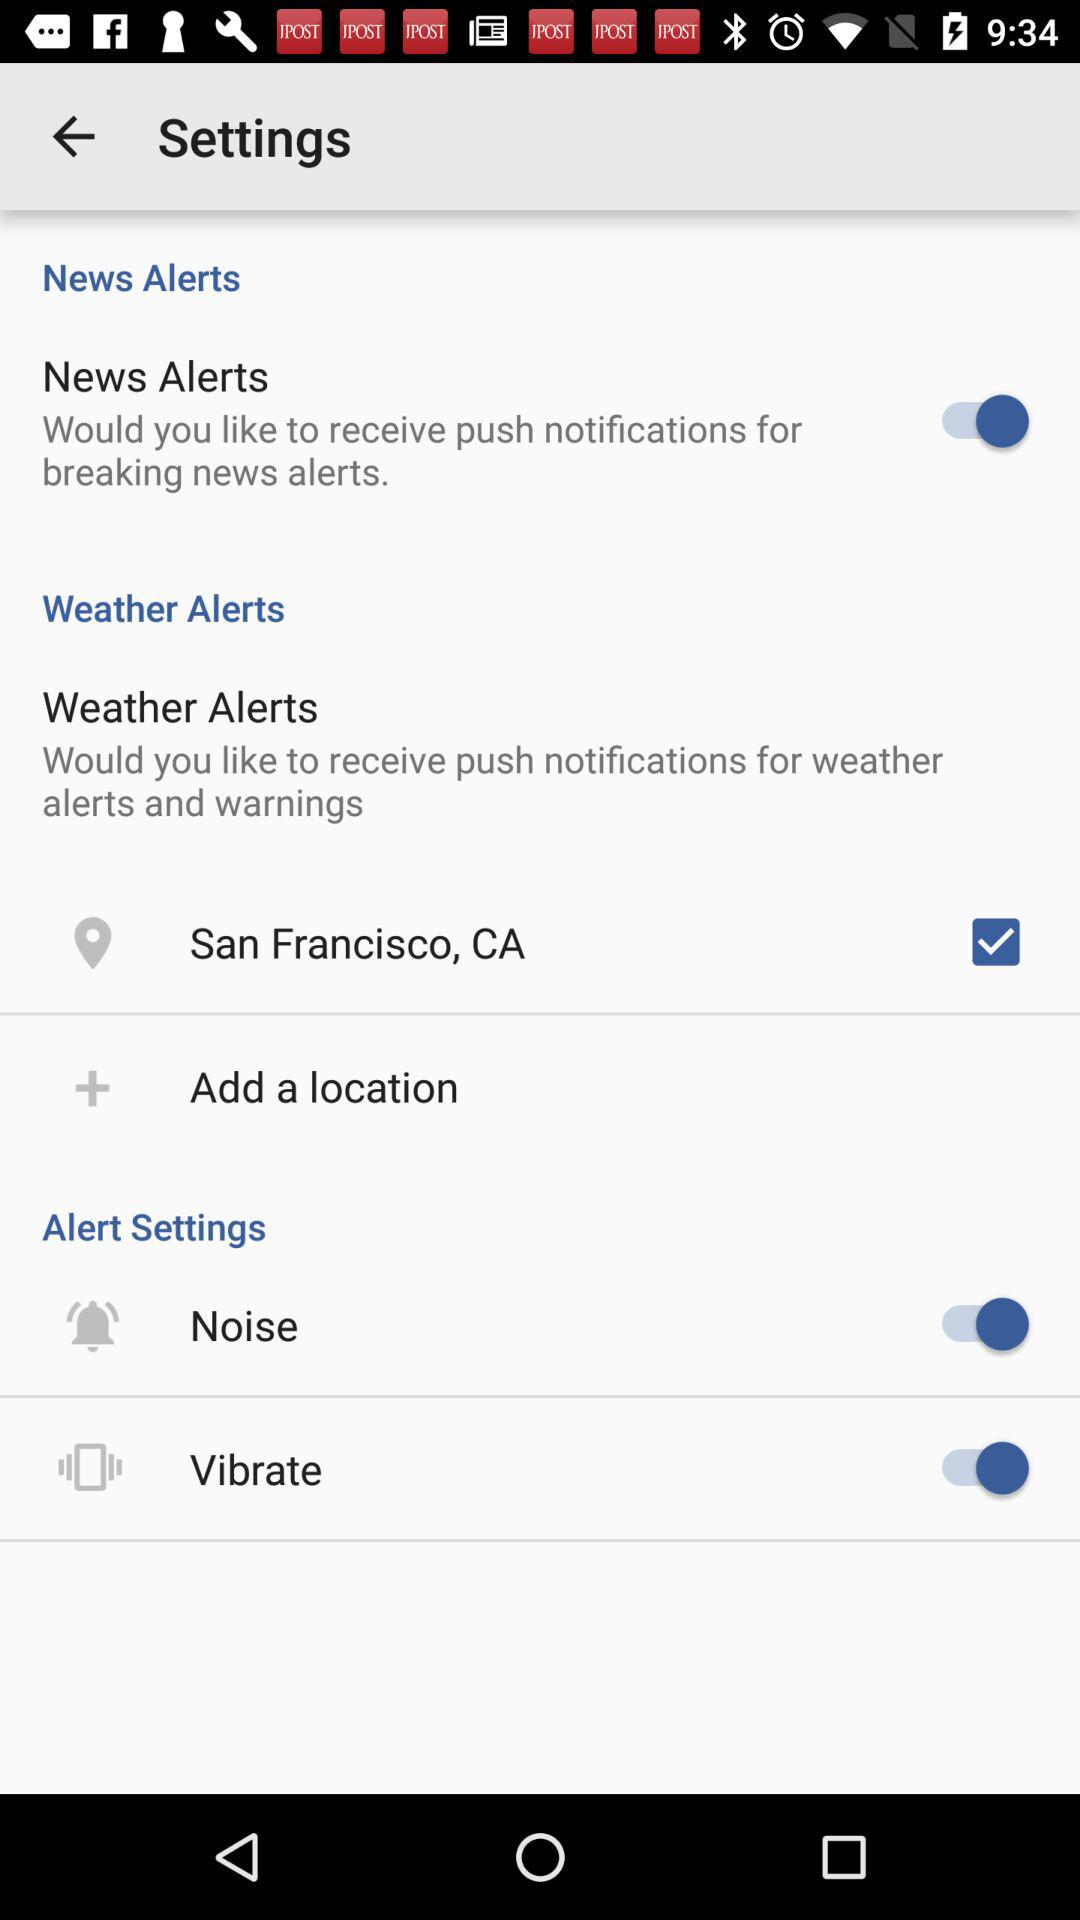How many alert settings are there that have a switch?
Answer the question using a single word or phrase. 2 